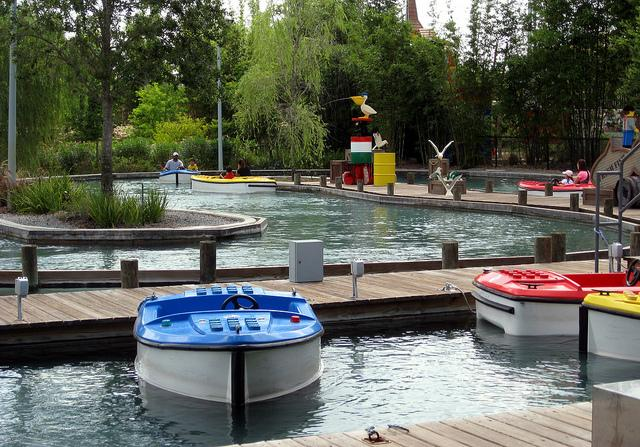What type of bird is on the red white and green barrel?

Choices:
A) eagle
B) swan
C) pelican
D) rooster pelican 